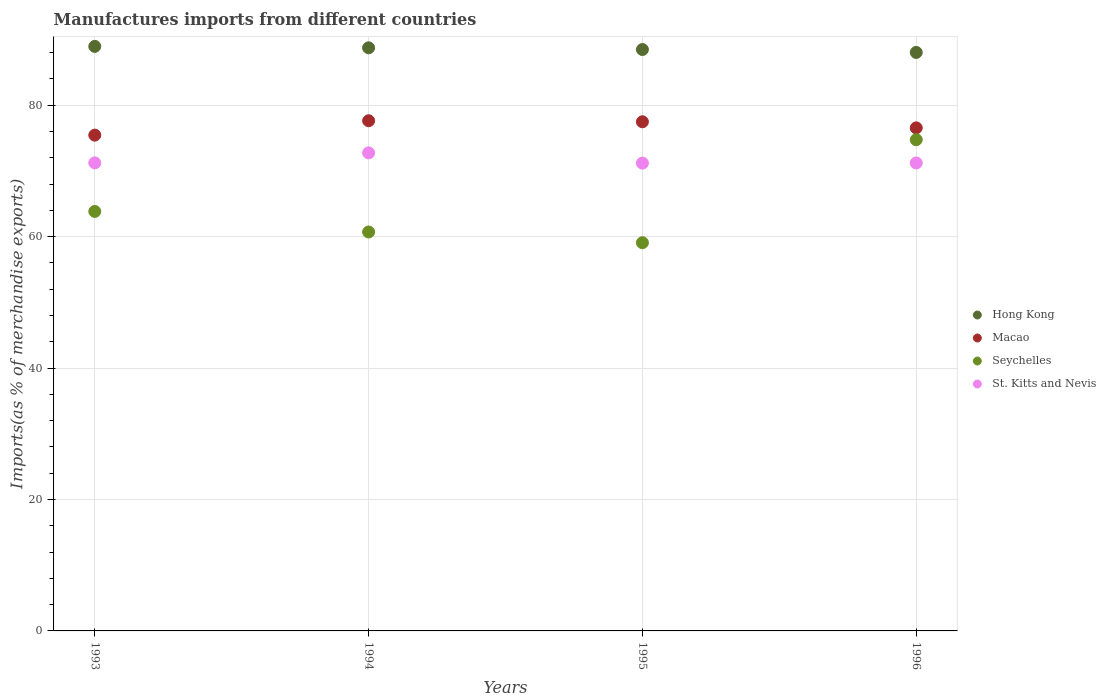What is the percentage of imports to different countries in Hong Kong in 1993?
Your answer should be compact. 88.95. Across all years, what is the maximum percentage of imports to different countries in St. Kitts and Nevis?
Your response must be concise. 72.75. Across all years, what is the minimum percentage of imports to different countries in Hong Kong?
Offer a very short reply. 88.03. What is the total percentage of imports to different countries in St. Kitts and Nevis in the graph?
Keep it short and to the point. 286.38. What is the difference between the percentage of imports to different countries in Seychelles in 1994 and that in 1995?
Give a very brief answer. 1.63. What is the difference between the percentage of imports to different countries in Hong Kong in 1994 and the percentage of imports to different countries in Seychelles in 1995?
Your answer should be very brief. 29.66. What is the average percentage of imports to different countries in St. Kitts and Nevis per year?
Offer a terse response. 71.59. In the year 1996, what is the difference between the percentage of imports to different countries in St. Kitts and Nevis and percentage of imports to different countries in Hong Kong?
Provide a succinct answer. -16.82. What is the ratio of the percentage of imports to different countries in Seychelles in 1993 to that in 1995?
Your answer should be compact. 1.08. What is the difference between the highest and the second highest percentage of imports to different countries in St. Kitts and Nevis?
Make the answer very short. 1.52. What is the difference between the highest and the lowest percentage of imports to different countries in Hong Kong?
Ensure brevity in your answer.  0.92. In how many years, is the percentage of imports to different countries in St. Kitts and Nevis greater than the average percentage of imports to different countries in St. Kitts and Nevis taken over all years?
Your answer should be compact. 1. Is the sum of the percentage of imports to different countries in Macao in 1993 and 1996 greater than the maximum percentage of imports to different countries in Hong Kong across all years?
Keep it short and to the point. Yes. Is it the case that in every year, the sum of the percentage of imports to different countries in Seychelles and percentage of imports to different countries in Hong Kong  is greater than the sum of percentage of imports to different countries in Macao and percentage of imports to different countries in St. Kitts and Nevis?
Provide a short and direct response. No. Does the percentage of imports to different countries in Macao monotonically increase over the years?
Ensure brevity in your answer.  No. Is the percentage of imports to different countries in Seychelles strictly greater than the percentage of imports to different countries in Hong Kong over the years?
Offer a very short reply. No. Is the percentage of imports to different countries in Hong Kong strictly less than the percentage of imports to different countries in Seychelles over the years?
Provide a short and direct response. No. How many legend labels are there?
Ensure brevity in your answer.  4. How are the legend labels stacked?
Make the answer very short. Vertical. What is the title of the graph?
Make the answer very short. Manufactures imports from different countries. Does "Finland" appear as one of the legend labels in the graph?
Provide a short and direct response. No. What is the label or title of the X-axis?
Make the answer very short. Years. What is the label or title of the Y-axis?
Make the answer very short. Imports(as % of merchandise exports). What is the Imports(as % of merchandise exports) in Hong Kong in 1993?
Keep it short and to the point. 88.95. What is the Imports(as % of merchandise exports) of Macao in 1993?
Ensure brevity in your answer.  75.45. What is the Imports(as % of merchandise exports) of Seychelles in 1993?
Keep it short and to the point. 63.83. What is the Imports(as % of merchandise exports) of St. Kitts and Nevis in 1993?
Provide a succinct answer. 71.23. What is the Imports(as % of merchandise exports) in Hong Kong in 1994?
Provide a succinct answer. 88.74. What is the Imports(as % of merchandise exports) in Macao in 1994?
Provide a succinct answer. 77.64. What is the Imports(as % of merchandise exports) of Seychelles in 1994?
Your response must be concise. 60.71. What is the Imports(as % of merchandise exports) in St. Kitts and Nevis in 1994?
Your response must be concise. 72.75. What is the Imports(as % of merchandise exports) in Hong Kong in 1995?
Provide a succinct answer. 88.48. What is the Imports(as % of merchandise exports) of Macao in 1995?
Provide a short and direct response. 77.48. What is the Imports(as % of merchandise exports) of Seychelles in 1995?
Your response must be concise. 59.08. What is the Imports(as % of merchandise exports) of St. Kitts and Nevis in 1995?
Your answer should be compact. 71.19. What is the Imports(as % of merchandise exports) of Hong Kong in 1996?
Offer a terse response. 88.03. What is the Imports(as % of merchandise exports) of Macao in 1996?
Make the answer very short. 76.55. What is the Imports(as % of merchandise exports) of Seychelles in 1996?
Ensure brevity in your answer.  74.75. What is the Imports(as % of merchandise exports) in St. Kitts and Nevis in 1996?
Make the answer very short. 71.21. Across all years, what is the maximum Imports(as % of merchandise exports) of Hong Kong?
Your answer should be very brief. 88.95. Across all years, what is the maximum Imports(as % of merchandise exports) in Macao?
Your answer should be very brief. 77.64. Across all years, what is the maximum Imports(as % of merchandise exports) in Seychelles?
Ensure brevity in your answer.  74.75. Across all years, what is the maximum Imports(as % of merchandise exports) in St. Kitts and Nevis?
Keep it short and to the point. 72.75. Across all years, what is the minimum Imports(as % of merchandise exports) of Hong Kong?
Provide a short and direct response. 88.03. Across all years, what is the minimum Imports(as % of merchandise exports) in Macao?
Your answer should be compact. 75.45. Across all years, what is the minimum Imports(as % of merchandise exports) of Seychelles?
Give a very brief answer. 59.08. Across all years, what is the minimum Imports(as % of merchandise exports) in St. Kitts and Nevis?
Give a very brief answer. 71.19. What is the total Imports(as % of merchandise exports) in Hong Kong in the graph?
Provide a succinct answer. 354.2. What is the total Imports(as % of merchandise exports) of Macao in the graph?
Make the answer very short. 307.12. What is the total Imports(as % of merchandise exports) in Seychelles in the graph?
Provide a short and direct response. 258.37. What is the total Imports(as % of merchandise exports) of St. Kitts and Nevis in the graph?
Your response must be concise. 286.38. What is the difference between the Imports(as % of merchandise exports) of Hong Kong in 1993 and that in 1994?
Your response must be concise. 0.22. What is the difference between the Imports(as % of merchandise exports) in Macao in 1993 and that in 1994?
Your answer should be compact. -2.19. What is the difference between the Imports(as % of merchandise exports) in Seychelles in 1993 and that in 1994?
Provide a succinct answer. 3.13. What is the difference between the Imports(as % of merchandise exports) of St. Kitts and Nevis in 1993 and that in 1994?
Give a very brief answer. -1.52. What is the difference between the Imports(as % of merchandise exports) in Hong Kong in 1993 and that in 1995?
Give a very brief answer. 0.48. What is the difference between the Imports(as % of merchandise exports) in Macao in 1993 and that in 1995?
Your answer should be very brief. -2.03. What is the difference between the Imports(as % of merchandise exports) in Seychelles in 1993 and that in 1995?
Your response must be concise. 4.76. What is the difference between the Imports(as % of merchandise exports) of St. Kitts and Nevis in 1993 and that in 1995?
Your answer should be very brief. 0.04. What is the difference between the Imports(as % of merchandise exports) of Hong Kong in 1993 and that in 1996?
Provide a succinct answer. 0.92. What is the difference between the Imports(as % of merchandise exports) in Macao in 1993 and that in 1996?
Keep it short and to the point. -1.1. What is the difference between the Imports(as % of merchandise exports) of Seychelles in 1993 and that in 1996?
Your response must be concise. -10.91. What is the difference between the Imports(as % of merchandise exports) of St. Kitts and Nevis in 1993 and that in 1996?
Ensure brevity in your answer.  0.01. What is the difference between the Imports(as % of merchandise exports) in Hong Kong in 1994 and that in 1995?
Offer a very short reply. 0.26. What is the difference between the Imports(as % of merchandise exports) in Macao in 1994 and that in 1995?
Make the answer very short. 0.16. What is the difference between the Imports(as % of merchandise exports) of Seychelles in 1994 and that in 1995?
Your answer should be compact. 1.63. What is the difference between the Imports(as % of merchandise exports) of St. Kitts and Nevis in 1994 and that in 1995?
Offer a terse response. 1.56. What is the difference between the Imports(as % of merchandise exports) in Hong Kong in 1994 and that in 1996?
Your response must be concise. 0.7. What is the difference between the Imports(as % of merchandise exports) in Macao in 1994 and that in 1996?
Your answer should be compact. 1.08. What is the difference between the Imports(as % of merchandise exports) of Seychelles in 1994 and that in 1996?
Provide a succinct answer. -14.04. What is the difference between the Imports(as % of merchandise exports) in St. Kitts and Nevis in 1994 and that in 1996?
Your answer should be compact. 1.54. What is the difference between the Imports(as % of merchandise exports) in Hong Kong in 1995 and that in 1996?
Offer a very short reply. 0.44. What is the difference between the Imports(as % of merchandise exports) of Macao in 1995 and that in 1996?
Keep it short and to the point. 0.93. What is the difference between the Imports(as % of merchandise exports) of Seychelles in 1995 and that in 1996?
Ensure brevity in your answer.  -15.67. What is the difference between the Imports(as % of merchandise exports) in St. Kitts and Nevis in 1995 and that in 1996?
Offer a terse response. -0.03. What is the difference between the Imports(as % of merchandise exports) of Hong Kong in 1993 and the Imports(as % of merchandise exports) of Macao in 1994?
Ensure brevity in your answer.  11.32. What is the difference between the Imports(as % of merchandise exports) of Hong Kong in 1993 and the Imports(as % of merchandise exports) of Seychelles in 1994?
Provide a short and direct response. 28.24. What is the difference between the Imports(as % of merchandise exports) in Hong Kong in 1993 and the Imports(as % of merchandise exports) in St. Kitts and Nevis in 1994?
Provide a short and direct response. 16.2. What is the difference between the Imports(as % of merchandise exports) of Macao in 1993 and the Imports(as % of merchandise exports) of Seychelles in 1994?
Offer a very short reply. 14.74. What is the difference between the Imports(as % of merchandise exports) in Macao in 1993 and the Imports(as % of merchandise exports) in St. Kitts and Nevis in 1994?
Offer a terse response. 2.7. What is the difference between the Imports(as % of merchandise exports) of Seychelles in 1993 and the Imports(as % of merchandise exports) of St. Kitts and Nevis in 1994?
Your response must be concise. -8.92. What is the difference between the Imports(as % of merchandise exports) of Hong Kong in 1993 and the Imports(as % of merchandise exports) of Macao in 1995?
Ensure brevity in your answer.  11.47. What is the difference between the Imports(as % of merchandise exports) of Hong Kong in 1993 and the Imports(as % of merchandise exports) of Seychelles in 1995?
Make the answer very short. 29.87. What is the difference between the Imports(as % of merchandise exports) in Hong Kong in 1993 and the Imports(as % of merchandise exports) in St. Kitts and Nevis in 1995?
Your answer should be very brief. 17.76. What is the difference between the Imports(as % of merchandise exports) of Macao in 1993 and the Imports(as % of merchandise exports) of Seychelles in 1995?
Ensure brevity in your answer.  16.37. What is the difference between the Imports(as % of merchandise exports) of Macao in 1993 and the Imports(as % of merchandise exports) of St. Kitts and Nevis in 1995?
Your answer should be compact. 4.26. What is the difference between the Imports(as % of merchandise exports) in Seychelles in 1993 and the Imports(as % of merchandise exports) in St. Kitts and Nevis in 1995?
Provide a short and direct response. -7.35. What is the difference between the Imports(as % of merchandise exports) in Hong Kong in 1993 and the Imports(as % of merchandise exports) in Macao in 1996?
Ensure brevity in your answer.  12.4. What is the difference between the Imports(as % of merchandise exports) in Hong Kong in 1993 and the Imports(as % of merchandise exports) in Seychelles in 1996?
Ensure brevity in your answer.  14.2. What is the difference between the Imports(as % of merchandise exports) of Hong Kong in 1993 and the Imports(as % of merchandise exports) of St. Kitts and Nevis in 1996?
Provide a short and direct response. 17.74. What is the difference between the Imports(as % of merchandise exports) in Macao in 1993 and the Imports(as % of merchandise exports) in Seychelles in 1996?
Your response must be concise. 0.7. What is the difference between the Imports(as % of merchandise exports) of Macao in 1993 and the Imports(as % of merchandise exports) of St. Kitts and Nevis in 1996?
Keep it short and to the point. 4.24. What is the difference between the Imports(as % of merchandise exports) of Seychelles in 1993 and the Imports(as % of merchandise exports) of St. Kitts and Nevis in 1996?
Your answer should be very brief. -7.38. What is the difference between the Imports(as % of merchandise exports) of Hong Kong in 1994 and the Imports(as % of merchandise exports) of Macao in 1995?
Offer a terse response. 11.26. What is the difference between the Imports(as % of merchandise exports) of Hong Kong in 1994 and the Imports(as % of merchandise exports) of Seychelles in 1995?
Give a very brief answer. 29.66. What is the difference between the Imports(as % of merchandise exports) of Hong Kong in 1994 and the Imports(as % of merchandise exports) of St. Kitts and Nevis in 1995?
Ensure brevity in your answer.  17.55. What is the difference between the Imports(as % of merchandise exports) of Macao in 1994 and the Imports(as % of merchandise exports) of Seychelles in 1995?
Offer a terse response. 18.56. What is the difference between the Imports(as % of merchandise exports) of Macao in 1994 and the Imports(as % of merchandise exports) of St. Kitts and Nevis in 1995?
Your answer should be very brief. 6.45. What is the difference between the Imports(as % of merchandise exports) of Seychelles in 1994 and the Imports(as % of merchandise exports) of St. Kitts and Nevis in 1995?
Provide a short and direct response. -10.48. What is the difference between the Imports(as % of merchandise exports) in Hong Kong in 1994 and the Imports(as % of merchandise exports) in Macao in 1996?
Offer a terse response. 12.18. What is the difference between the Imports(as % of merchandise exports) of Hong Kong in 1994 and the Imports(as % of merchandise exports) of Seychelles in 1996?
Provide a succinct answer. 13.99. What is the difference between the Imports(as % of merchandise exports) of Hong Kong in 1994 and the Imports(as % of merchandise exports) of St. Kitts and Nevis in 1996?
Make the answer very short. 17.52. What is the difference between the Imports(as % of merchandise exports) in Macao in 1994 and the Imports(as % of merchandise exports) in Seychelles in 1996?
Your answer should be compact. 2.89. What is the difference between the Imports(as % of merchandise exports) of Macao in 1994 and the Imports(as % of merchandise exports) of St. Kitts and Nevis in 1996?
Ensure brevity in your answer.  6.42. What is the difference between the Imports(as % of merchandise exports) in Seychelles in 1994 and the Imports(as % of merchandise exports) in St. Kitts and Nevis in 1996?
Your response must be concise. -10.5. What is the difference between the Imports(as % of merchandise exports) in Hong Kong in 1995 and the Imports(as % of merchandise exports) in Macao in 1996?
Give a very brief answer. 11.93. What is the difference between the Imports(as % of merchandise exports) of Hong Kong in 1995 and the Imports(as % of merchandise exports) of Seychelles in 1996?
Offer a terse response. 13.73. What is the difference between the Imports(as % of merchandise exports) of Hong Kong in 1995 and the Imports(as % of merchandise exports) of St. Kitts and Nevis in 1996?
Keep it short and to the point. 17.26. What is the difference between the Imports(as % of merchandise exports) of Macao in 1995 and the Imports(as % of merchandise exports) of Seychelles in 1996?
Provide a succinct answer. 2.73. What is the difference between the Imports(as % of merchandise exports) in Macao in 1995 and the Imports(as % of merchandise exports) in St. Kitts and Nevis in 1996?
Give a very brief answer. 6.27. What is the difference between the Imports(as % of merchandise exports) of Seychelles in 1995 and the Imports(as % of merchandise exports) of St. Kitts and Nevis in 1996?
Keep it short and to the point. -12.14. What is the average Imports(as % of merchandise exports) in Hong Kong per year?
Offer a terse response. 88.55. What is the average Imports(as % of merchandise exports) of Macao per year?
Your response must be concise. 76.78. What is the average Imports(as % of merchandise exports) of Seychelles per year?
Your answer should be compact. 64.59. What is the average Imports(as % of merchandise exports) in St. Kitts and Nevis per year?
Ensure brevity in your answer.  71.59. In the year 1993, what is the difference between the Imports(as % of merchandise exports) in Hong Kong and Imports(as % of merchandise exports) in Macao?
Ensure brevity in your answer.  13.5. In the year 1993, what is the difference between the Imports(as % of merchandise exports) of Hong Kong and Imports(as % of merchandise exports) of Seychelles?
Your answer should be very brief. 25.12. In the year 1993, what is the difference between the Imports(as % of merchandise exports) of Hong Kong and Imports(as % of merchandise exports) of St. Kitts and Nevis?
Offer a very short reply. 17.72. In the year 1993, what is the difference between the Imports(as % of merchandise exports) of Macao and Imports(as % of merchandise exports) of Seychelles?
Provide a short and direct response. 11.61. In the year 1993, what is the difference between the Imports(as % of merchandise exports) of Macao and Imports(as % of merchandise exports) of St. Kitts and Nevis?
Your response must be concise. 4.22. In the year 1993, what is the difference between the Imports(as % of merchandise exports) of Seychelles and Imports(as % of merchandise exports) of St. Kitts and Nevis?
Offer a terse response. -7.39. In the year 1994, what is the difference between the Imports(as % of merchandise exports) of Hong Kong and Imports(as % of merchandise exports) of Macao?
Your answer should be compact. 11.1. In the year 1994, what is the difference between the Imports(as % of merchandise exports) in Hong Kong and Imports(as % of merchandise exports) in Seychelles?
Offer a terse response. 28.03. In the year 1994, what is the difference between the Imports(as % of merchandise exports) in Hong Kong and Imports(as % of merchandise exports) in St. Kitts and Nevis?
Your answer should be very brief. 15.99. In the year 1994, what is the difference between the Imports(as % of merchandise exports) of Macao and Imports(as % of merchandise exports) of Seychelles?
Ensure brevity in your answer.  16.93. In the year 1994, what is the difference between the Imports(as % of merchandise exports) in Macao and Imports(as % of merchandise exports) in St. Kitts and Nevis?
Ensure brevity in your answer.  4.89. In the year 1994, what is the difference between the Imports(as % of merchandise exports) in Seychelles and Imports(as % of merchandise exports) in St. Kitts and Nevis?
Offer a terse response. -12.04. In the year 1995, what is the difference between the Imports(as % of merchandise exports) of Hong Kong and Imports(as % of merchandise exports) of Macao?
Your response must be concise. 11. In the year 1995, what is the difference between the Imports(as % of merchandise exports) in Hong Kong and Imports(as % of merchandise exports) in Seychelles?
Your answer should be very brief. 29.4. In the year 1995, what is the difference between the Imports(as % of merchandise exports) of Hong Kong and Imports(as % of merchandise exports) of St. Kitts and Nevis?
Offer a very short reply. 17.29. In the year 1995, what is the difference between the Imports(as % of merchandise exports) in Macao and Imports(as % of merchandise exports) in Seychelles?
Give a very brief answer. 18.4. In the year 1995, what is the difference between the Imports(as % of merchandise exports) of Macao and Imports(as % of merchandise exports) of St. Kitts and Nevis?
Ensure brevity in your answer.  6.29. In the year 1995, what is the difference between the Imports(as % of merchandise exports) of Seychelles and Imports(as % of merchandise exports) of St. Kitts and Nevis?
Provide a short and direct response. -12.11. In the year 1996, what is the difference between the Imports(as % of merchandise exports) in Hong Kong and Imports(as % of merchandise exports) in Macao?
Your answer should be very brief. 11.48. In the year 1996, what is the difference between the Imports(as % of merchandise exports) of Hong Kong and Imports(as % of merchandise exports) of Seychelles?
Provide a short and direct response. 13.29. In the year 1996, what is the difference between the Imports(as % of merchandise exports) in Hong Kong and Imports(as % of merchandise exports) in St. Kitts and Nevis?
Your response must be concise. 16.82. In the year 1996, what is the difference between the Imports(as % of merchandise exports) in Macao and Imports(as % of merchandise exports) in Seychelles?
Your answer should be very brief. 1.8. In the year 1996, what is the difference between the Imports(as % of merchandise exports) of Macao and Imports(as % of merchandise exports) of St. Kitts and Nevis?
Your response must be concise. 5.34. In the year 1996, what is the difference between the Imports(as % of merchandise exports) of Seychelles and Imports(as % of merchandise exports) of St. Kitts and Nevis?
Your answer should be very brief. 3.54. What is the ratio of the Imports(as % of merchandise exports) in Macao in 1993 to that in 1994?
Offer a terse response. 0.97. What is the ratio of the Imports(as % of merchandise exports) in Seychelles in 1993 to that in 1994?
Keep it short and to the point. 1.05. What is the ratio of the Imports(as % of merchandise exports) in St. Kitts and Nevis in 1993 to that in 1994?
Offer a terse response. 0.98. What is the ratio of the Imports(as % of merchandise exports) in Hong Kong in 1993 to that in 1995?
Make the answer very short. 1.01. What is the ratio of the Imports(as % of merchandise exports) in Macao in 1993 to that in 1995?
Offer a terse response. 0.97. What is the ratio of the Imports(as % of merchandise exports) in Seychelles in 1993 to that in 1995?
Make the answer very short. 1.08. What is the ratio of the Imports(as % of merchandise exports) in Hong Kong in 1993 to that in 1996?
Give a very brief answer. 1.01. What is the ratio of the Imports(as % of merchandise exports) of Macao in 1993 to that in 1996?
Keep it short and to the point. 0.99. What is the ratio of the Imports(as % of merchandise exports) of Seychelles in 1993 to that in 1996?
Provide a short and direct response. 0.85. What is the ratio of the Imports(as % of merchandise exports) of Hong Kong in 1994 to that in 1995?
Provide a succinct answer. 1. What is the ratio of the Imports(as % of merchandise exports) in Seychelles in 1994 to that in 1995?
Offer a very short reply. 1.03. What is the ratio of the Imports(as % of merchandise exports) in St. Kitts and Nevis in 1994 to that in 1995?
Offer a very short reply. 1.02. What is the ratio of the Imports(as % of merchandise exports) of Hong Kong in 1994 to that in 1996?
Keep it short and to the point. 1.01. What is the ratio of the Imports(as % of merchandise exports) in Macao in 1994 to that in 1996?
Your response must be concise. 1.01. What is the ratio of the Imports(as % of merchandise exports) in Seychelles in 1994 to that in 1996?
Keep it short and to the point. 0.81. What is the ratio of the Imports(as % of merchandise exports) of St. Kitts and Nevis in 1994 to that in 1996?
Your response must be concise. 1.02. What is the ratio of the Imports(as % of merchandise exports) in Macao in 1995 to that in 1996?
Your response must be concise. 1.01. What is the ratio of the Imports(as % of merchandise exports) in Seychelles in 1995 to that in 1996?
Your response must be concise. 0.79. What is the difference between the highest and the second highest Imports(as % of merchandise exports) in Hong Kong?
Provide a succinct answer. 0.22. What is the difference between the highest and the second highest Imports(as % of merchandise exports) of Macao?
Keep it short and to the point. 0.16. What is the difference between the highest and the second highest Imports(as % of merchandise exports) in Seychelles?
Offer a terse response. 10.91. What is the difference between the highest and the second highest Imports(as % of merchandise exports) of St. Kitts and Nevis?
Ensure brevity in your answer.  1.52. What is the difference between the highest and the lowest Imports(as % of merchandise exports) in Hong Kong?
Make the answer very short. 0.92. What is the difference between the highest and the lowest Imports(as % of merchandise exports) in Macao?
Offer a very short reply. 2.19. What is the difference between the highest and the lowest Imports(as % of merchandise exports) of Seychelles?
Offer a very short reply. 15.67. What is the difference between the highest and the lowest Imports(as % of merchandise exports) of St. Kitts and Nevis?
Provide a succinct answer. 1.56. 